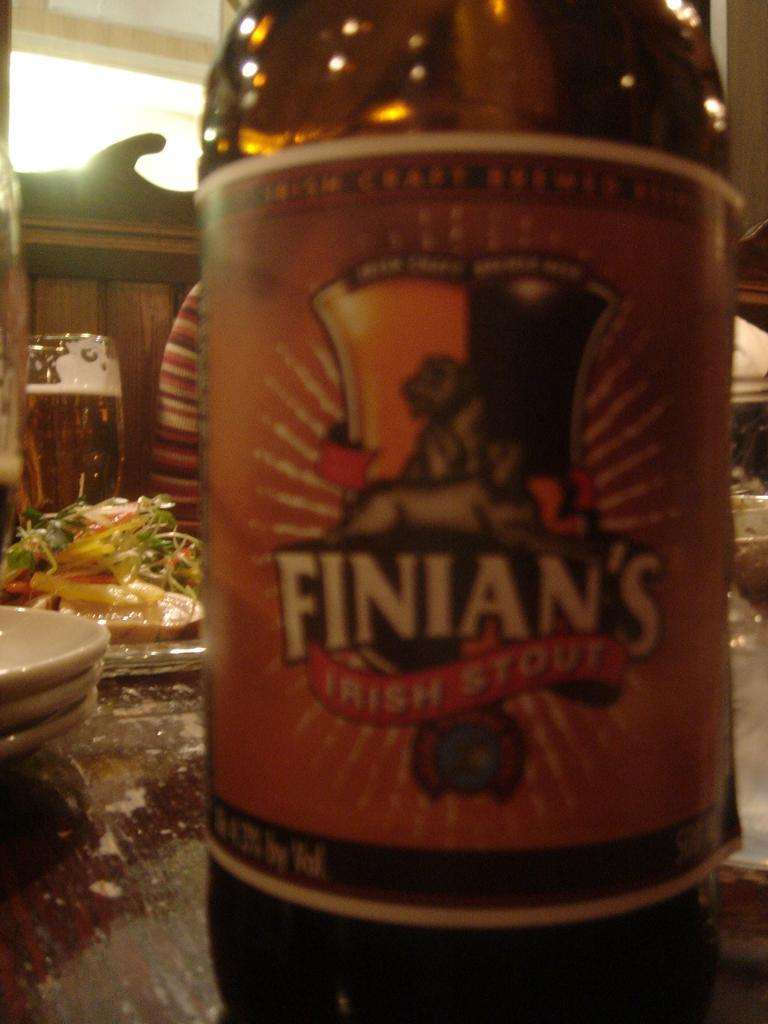<image>
Summarize the visual content of the image. A bottle of Finian's is on a dinner table with food. 